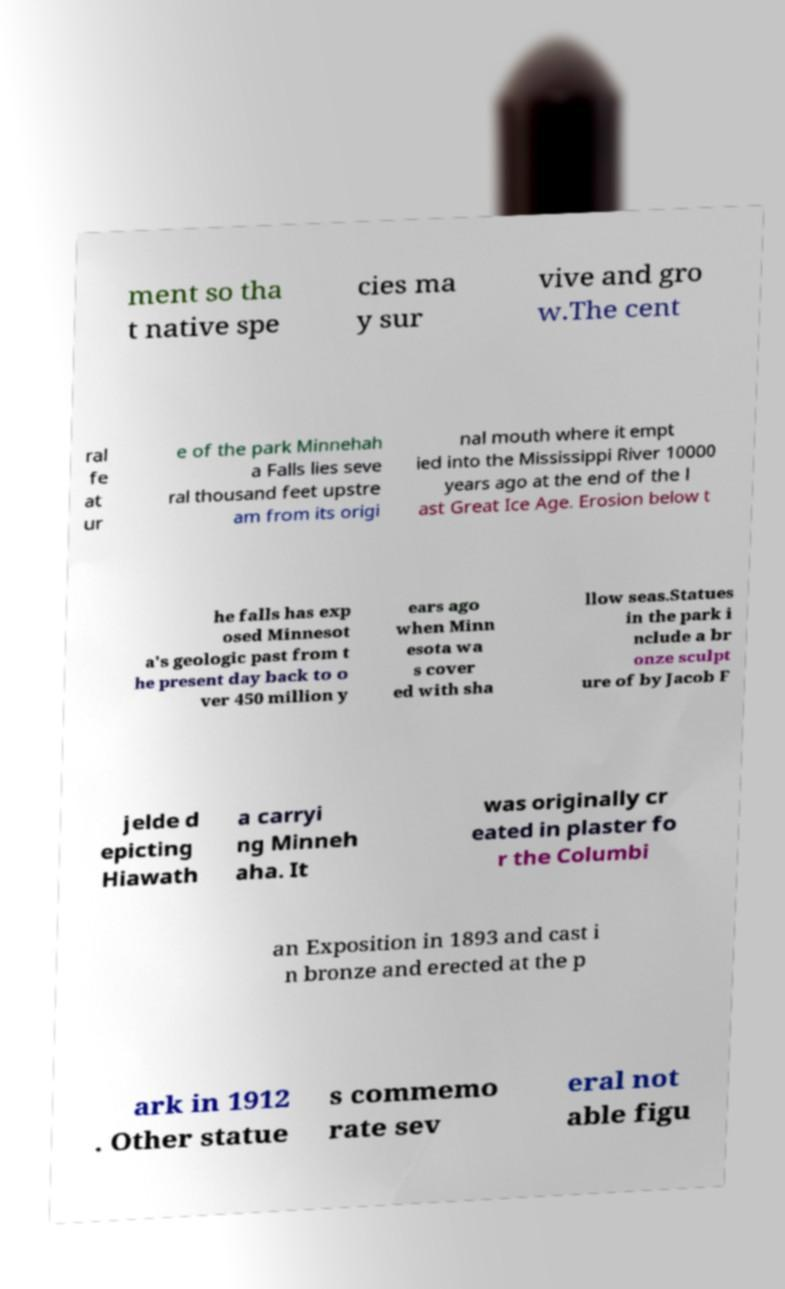Could you extract and type out the text from this image? ment so tha t native spe cies ma y sur vive and gro w.The cent ral fe at ur e of the park Minnehah a Falls lies seve ral thousand feet upstre am from its origi nal mouth where it empt ied into the Mississippi River 10000 years ago at the end of the l ast Great Ice Age. Erosion below t he falls has exp osed Minnesot a's geologic past from t he present day back to o ver 450 million y ears ago when Minn esota wa s cover ed with sha llow seas.Statues in the park i nclude a br onze sculpt ure of by Jacob F jelde d epicting Hiawath a carryi ng Minneh aha. It was originally cr eated in plaster fo r the Columbi an Exposition in 1893 and cast i n bronze and erected at the p ark in 1912 . Other statue s commemo rate sev eral not able figu 